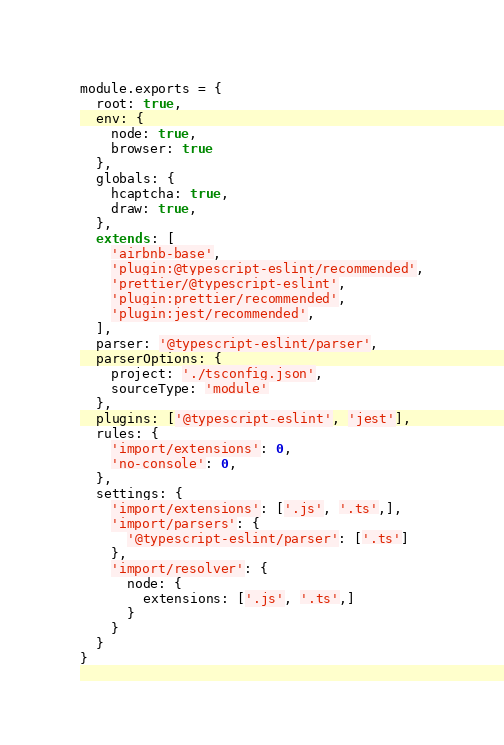Convert code to text. <code><loc_0><loc_0><loc_500><loc_500><_JavaScript_>module.exports = {
  root: true,
  env: {
    node: true,
    browser: true
  },
  globals: {
    hcaptcha: true,
    draw: true,
  },
  extends: [
    'airbnb-base',
    'plugin:@typescript-eslint/recommended',
    'prettier/@typescript-eslint',
    'plugin:prettier/recommended',
    'plugin:jest/recommended',
  ],
  parser: '@typescript-eslint/parser',
  parserOptions: {
    project: './tsconfig.json',
    sourceType: 'module'
  },
  plugins: ['@typescript-eslint', 'jest'],
  rules: {
    'import/extensions': 0,
    'no-console': 0,
  },
  settings: {
    'import/extensions': ['.js', '.ts',],
    'import/parsers': {
      '@typescript-eslint/parser': ['.ts']
    },
    'import/resolver': {
      node: {
        extensions: ['.js', '.ts',]
      }
    }
  }
}</code> 